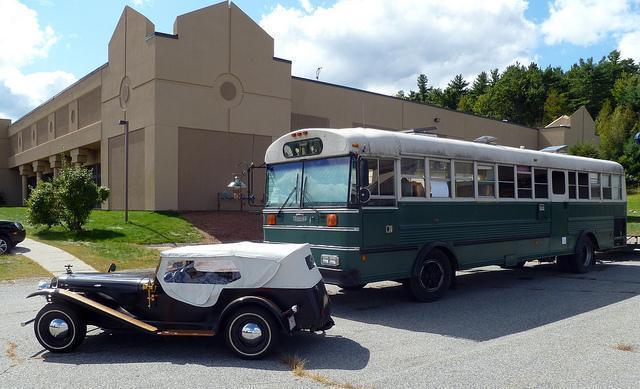Who is in danger of being struc?
Make your selection and explain in format: 'Answer: answer
Rationale: rationale.'
Options: Car, bus, building, parked car. Answer: car.
Rationale: The car  comes across the bus hence chance of being hit. 